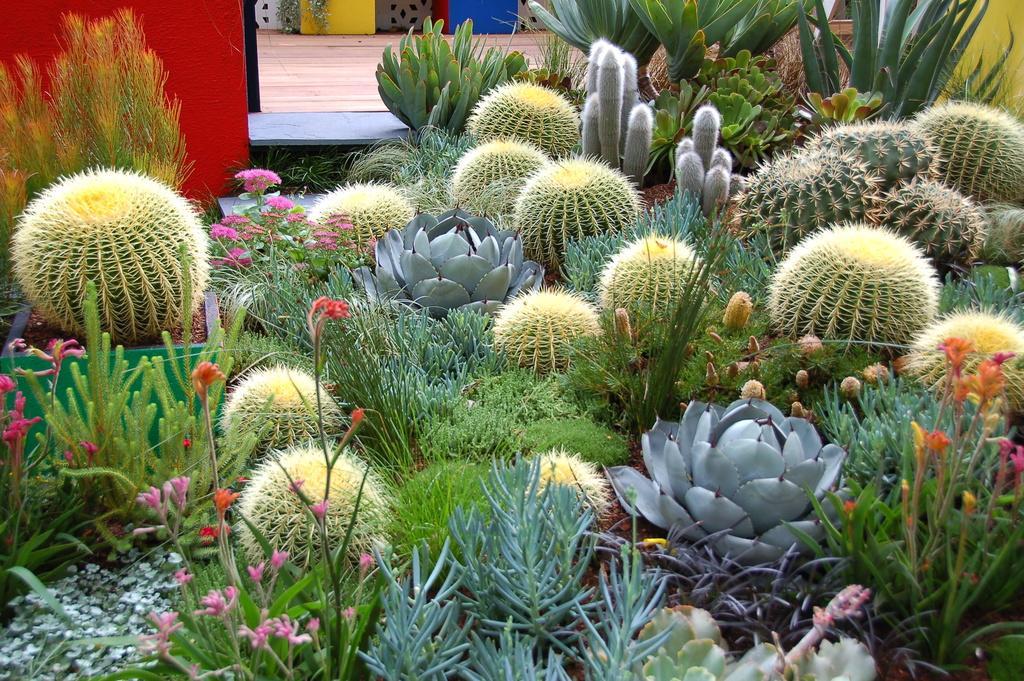Please provide a concise description of this image. The picture consists of cactus plants, flowers and variety of plants. At the top there is pavement and wall. 